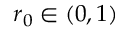<formula> <loc_0><loc_0><loc_500><loc_500>r _ { 0 } \in ( 0 , 1 )</formula> 